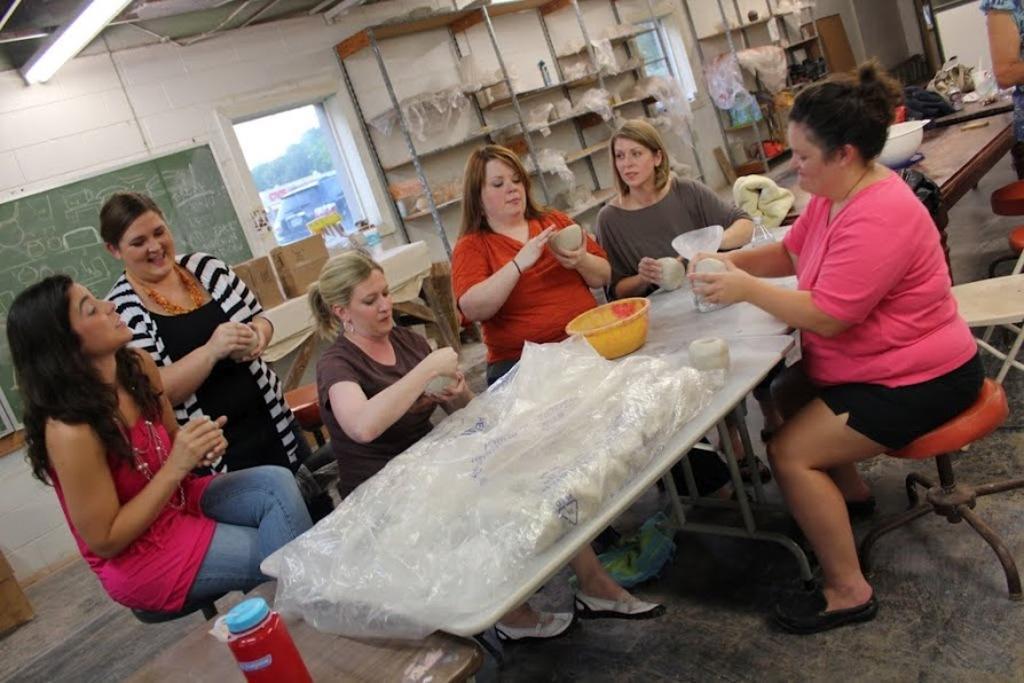In one or two sentences, can you explain what this image depicts? In this image we can see few people sitting. One lady is standing. They are holding something in the hand. There are tables. On the table there is plastic cover, bowl and some other items. In the back there is a door. Also there are cupboards. And there are some items in the cupboard. Also there is a board on the wall. There is a bottle at the bottom. Also there are stools. 